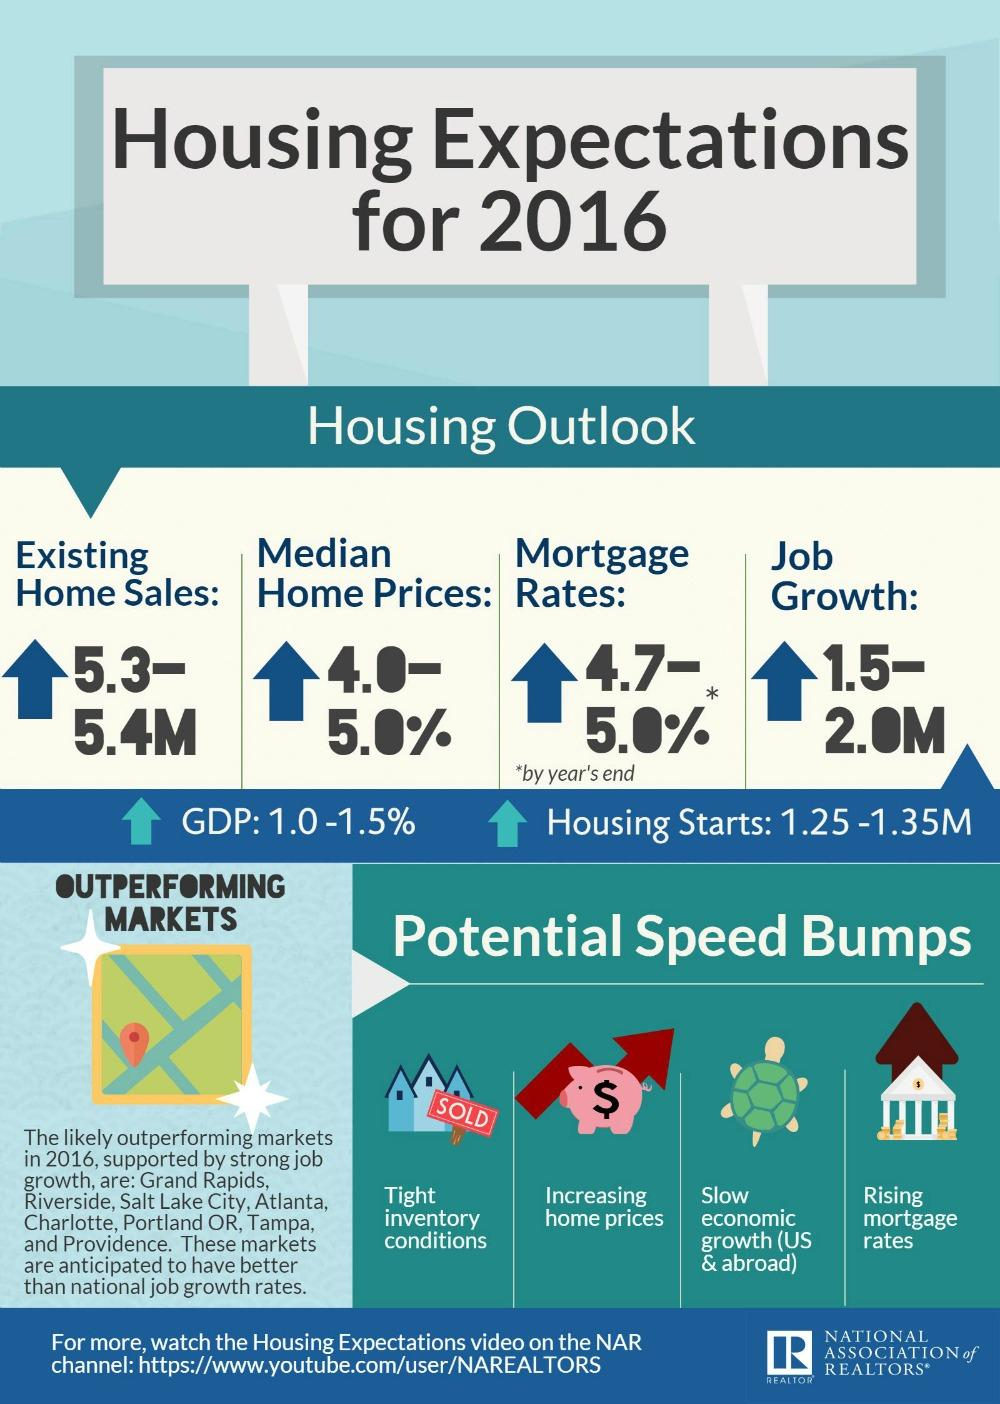Draw attention to some important aspects in this diagram. The existing home sales in 2016 ranged from approximately 5.3 million to 5.4 million, with a median of 1.5 million to 2 million, and a lower quartile of 1.25 million to 1.35 million. 